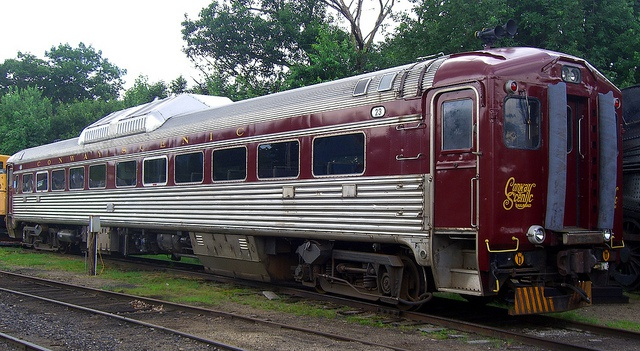Describe the objects in this image and their specific colors. I can see a train in white, black, gray, darkgray, and lightgray tones in this image. 